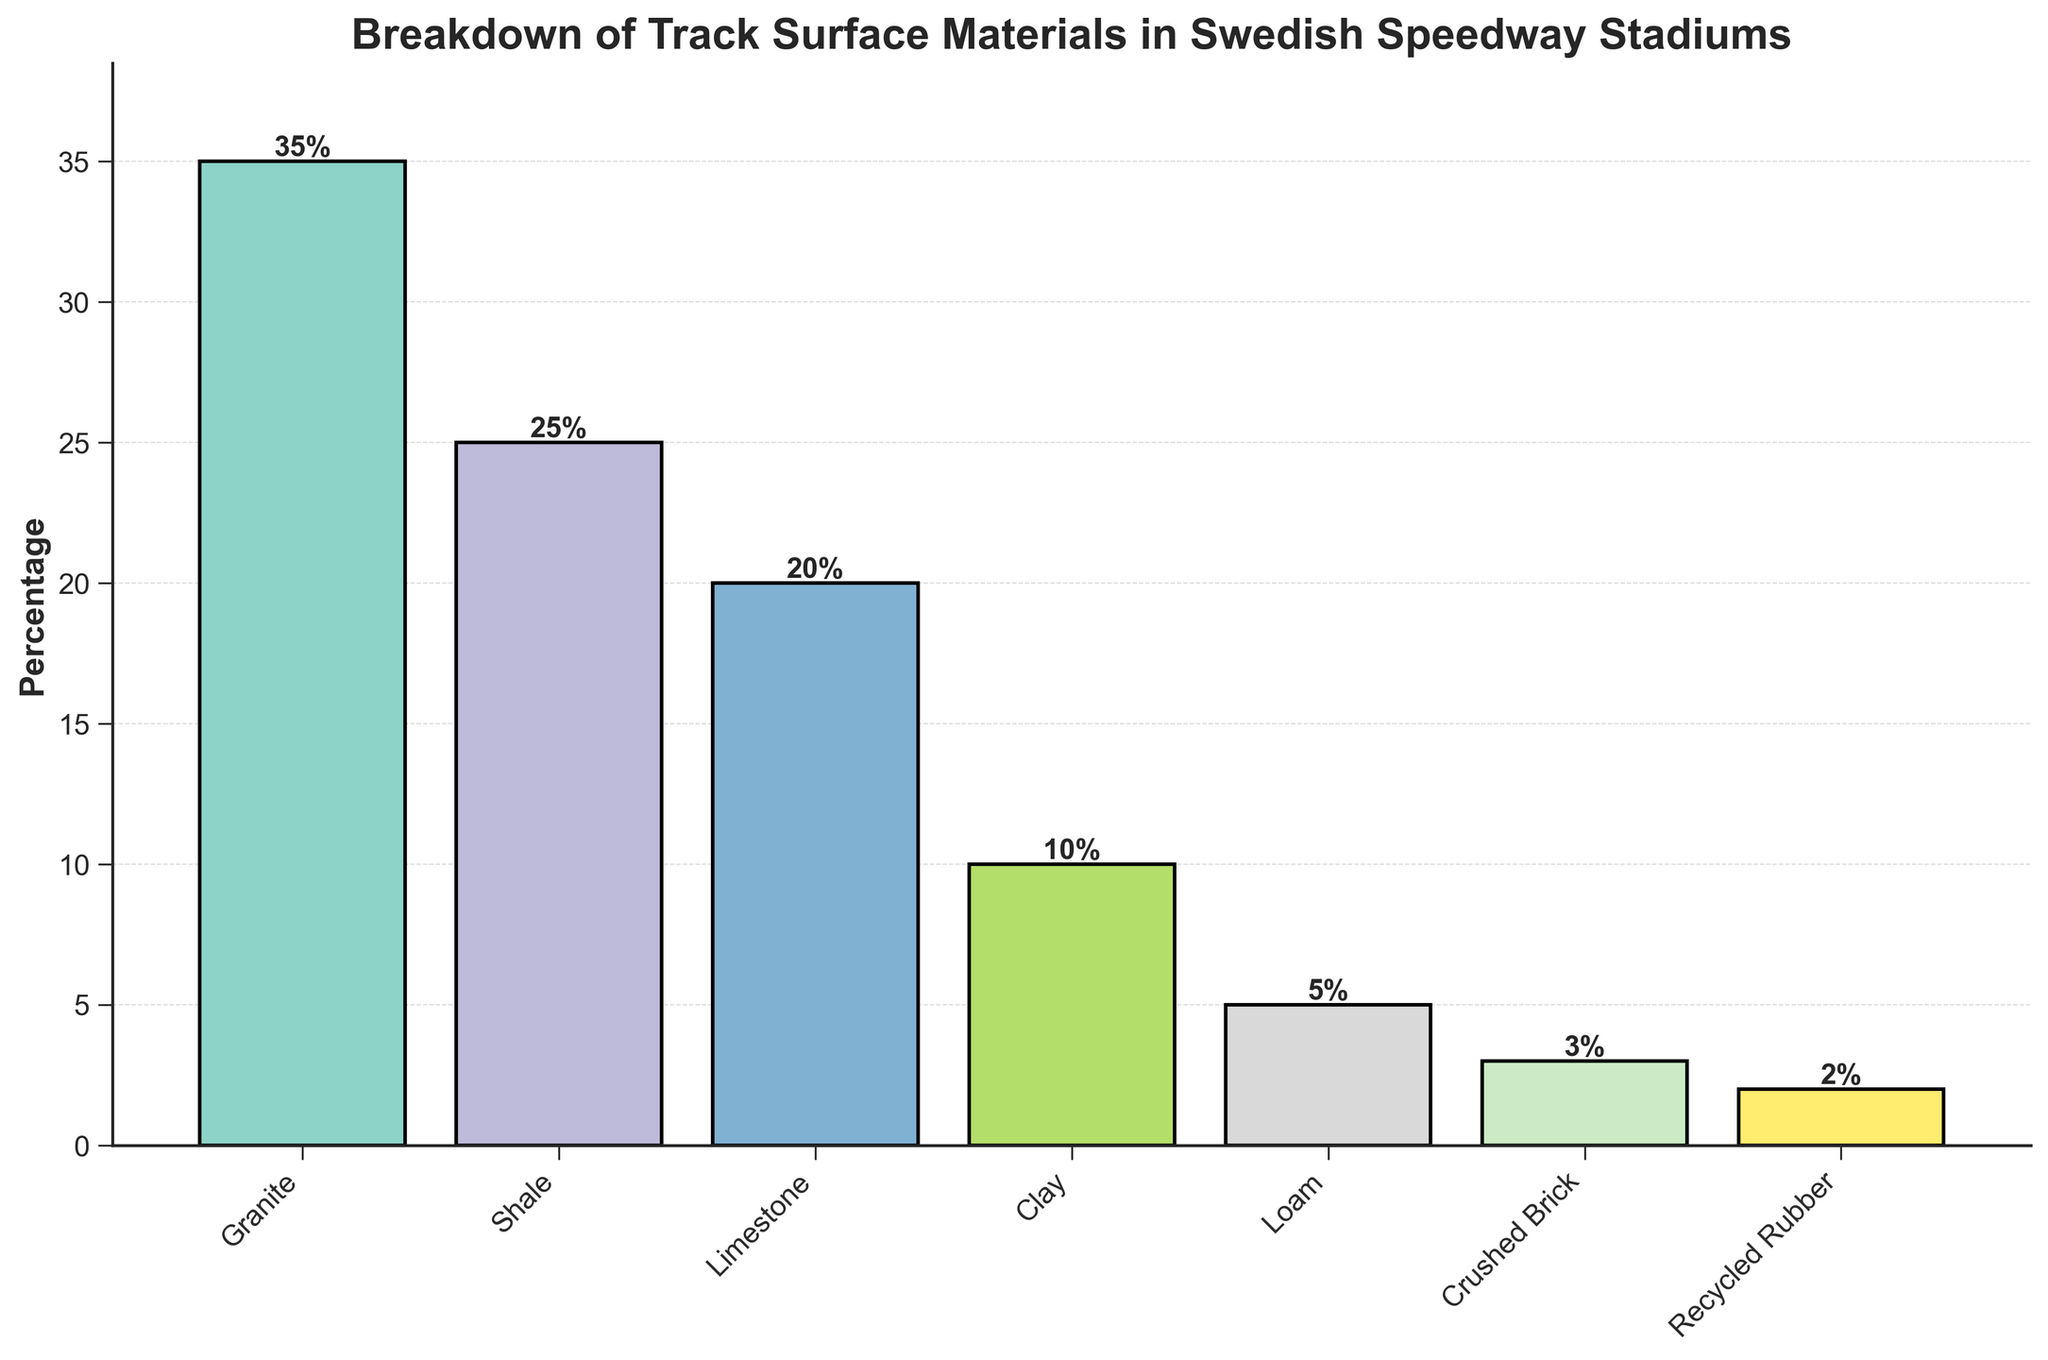What is the most common track surface material used in Swedish speedway stadiums? The bar corresponding to Granite is the tallest, indicating it has the highest percentage.
Answer: Granite Which track surface material has the smallest percentage? The shortest bar in the plot represents Recycled Rubber, indicating it has the smallest percentage.
Answer: Recycled Rubber What is the combined percentage of Granite and Shale track surfaces? The height of the Granite bar is 35% and the Shale bar is 25%; adding these percentages together: 35% + 25% = 60%.
Answer: 60% How much higher is the percentage of Granite than Limestone? The percentage of Granite is 35%, and the percentage of Limestone is 20%; subtracting the smaller from the larger: 35% - 20% = 15%.
Answer: 15% Which two surface materials have a combined percentage of exactly 13%? The percentages for Crushed Brick and Recycled Rubber are 3% and 2%, respectively. These do not add up to 13%. However, adding the percentages of Clay and Crushed Brick (10% + 3%): 10% + 3% = 13%.
Answer: Clay and Crushed Brick What is the average percentage of the top three most common track surface materials? The top three percentages are: Granite (35%), Shale (25%), and Limestone (20%). Adding them gives: 35% + 25% + 20% = 80%. Dividing by 3 gives the average: 80% / 3 ≈ 26.67%.
Answer: 26.67% Rank the track surface materials from highest to lowest percentage. By observing the heights of the bars: Granite (35%), Shale (25%), Limestone (20%), Clay (10%), Loam (5%), Crushed Brick (3%), Recycled Rubber (2%).
Answer: Granite, Shale, Limestone, Clay, Loam, Crushed Brick, Recycled Rubber Identify a surface material that has double the percentage of another. Comparing heights, Loam has 5%, which is double Recycled Rubber's 2.5%. However, taking into consideration only used percentages, Limestone at 20% is double Crushed Brick's 10%.
Answer: Limestone and Crushed Brick 